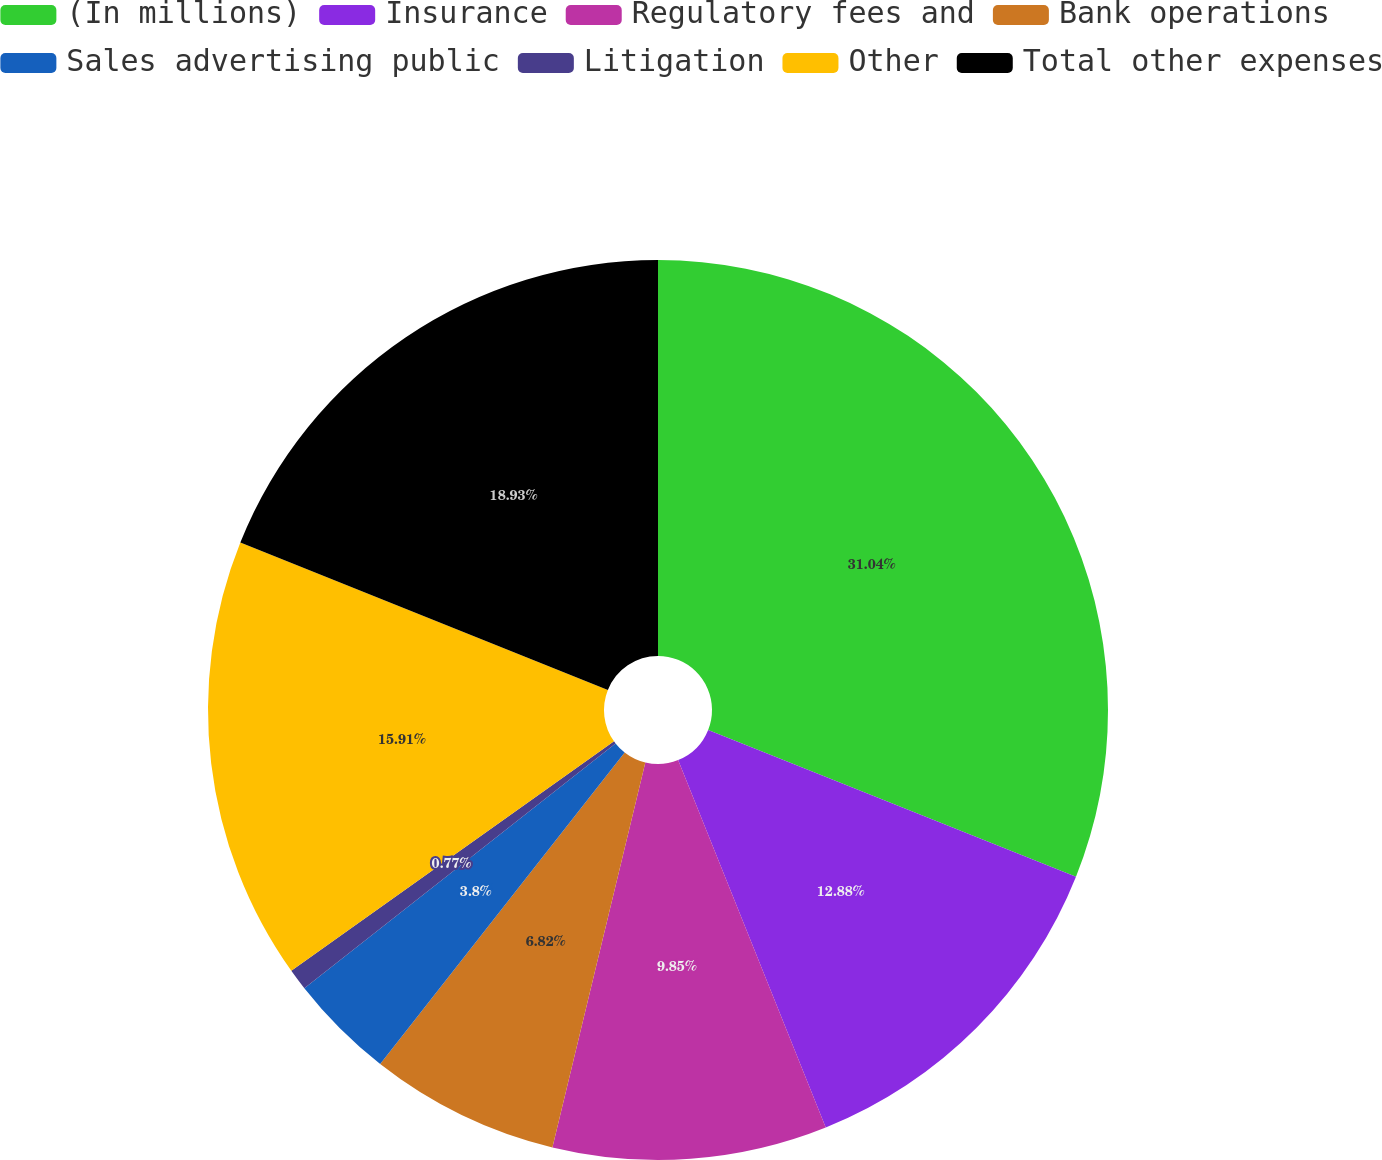Convert chart to OTSL. <chart><loc_0><loc_0><loc_500><loc_500><pie_chart><fcel>(In millions)<fcel>Insurance<fcel>Regulatory fees and<fcel>Bank operations<fcel>Sales advertising public<fcel>Litigation<fcel>Other<fcel>Total other expenses<nl><fcel>31.04%<fcel>12.88%<fcel>9.85%<fcel>6.82%<fcel>3.8%<fcel>0.77%<fcel>15.91%<fcel>18.93%<nl></chart> 